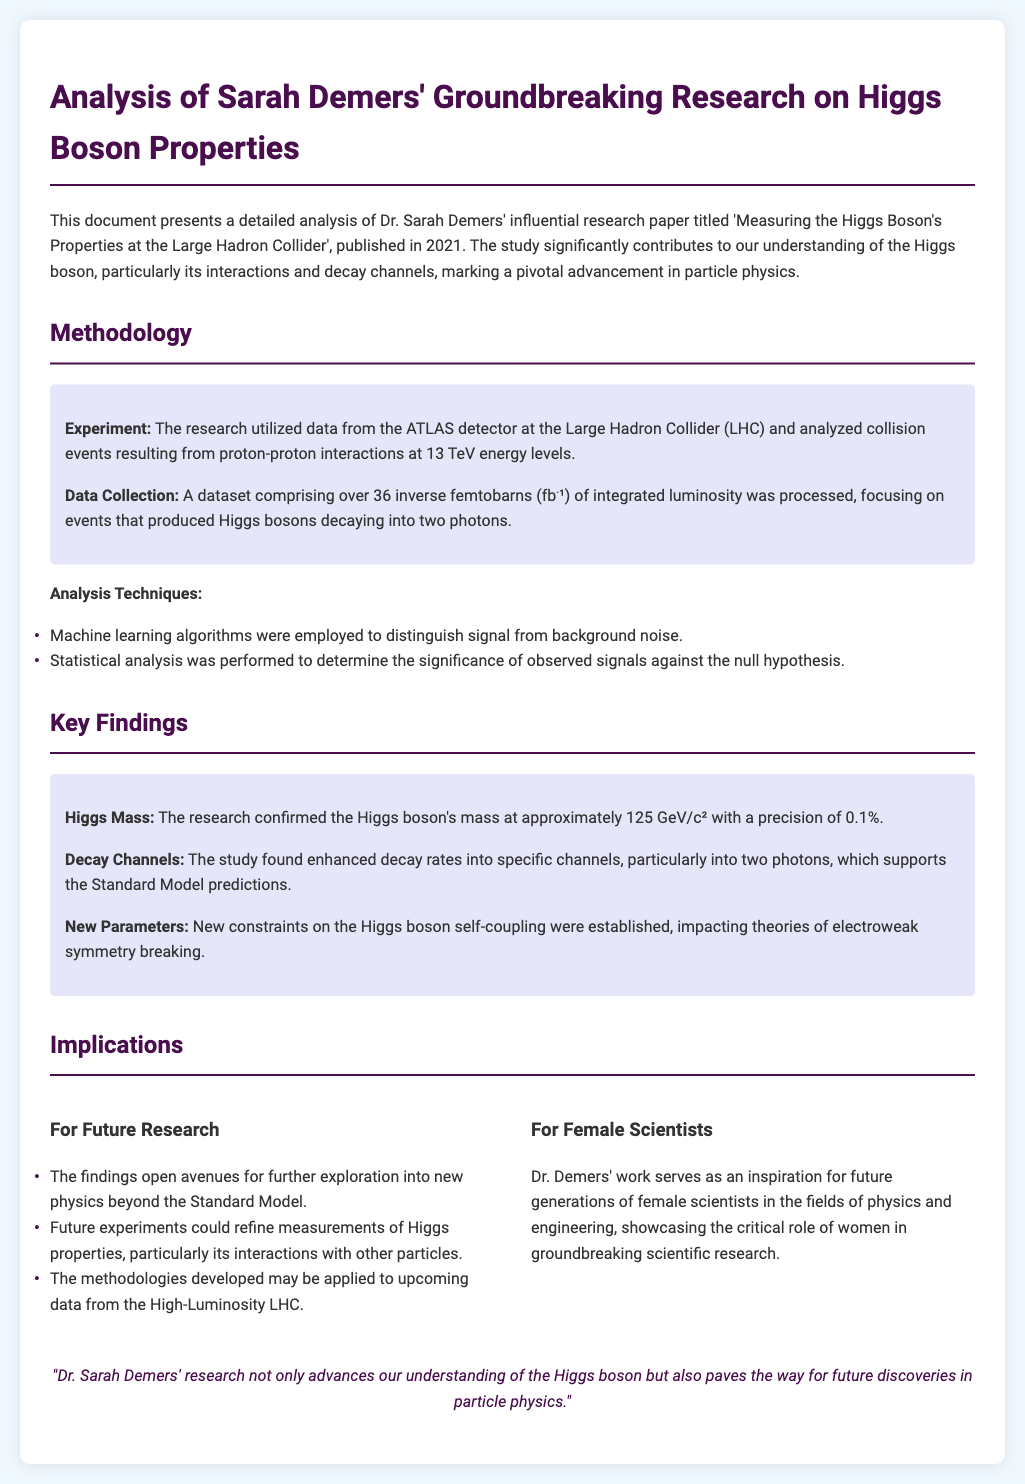What year was Sarah Demers' research paper published? The document states that the paper was published in 2021.
Answer: 2021 What was the energy level of the proton-proton interactions studied? The research analyzed collision events at 13 TeV energy levels.
Answer: 13 TeV What technique was used to distinguish signal from background noise? The methodology involved employing machine learning algorithms for distinguishing signals.
Answer: Machine learning algorithms What was the confirmed mass of the Higgs boson? The research confirmed the Higgs boson's mass at approximately 125 GeV/c².
Answer: 125 GeV/c² What significant parameter related to Higgs boson self-coupling was established? The study established new constraints on the Higgs boson self-coupling.
Answer: New constraints What implication does Dr. Demers' work have for future generations of female scientists? It showcases the critical role of women in groundbreaking scientific research.
Answer: Inspiration Which decay channel had enhanced rates supporting the Standard Model predictions? The study found enhanced decay rates into two photons.
Answer: Two photons What is the total integrated luminosity of the dataset used in the research? The dataset comprised over 36 inverse femtobarns of integrated luminosity.
Answer: 36 inverse femtobarns 